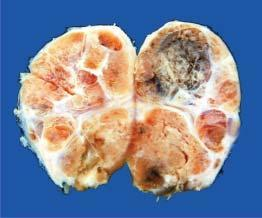does cut surface show multiple nodules separated from each other by incomplete fibrous septa?
Answer the question using a single word or phrase. Yes 